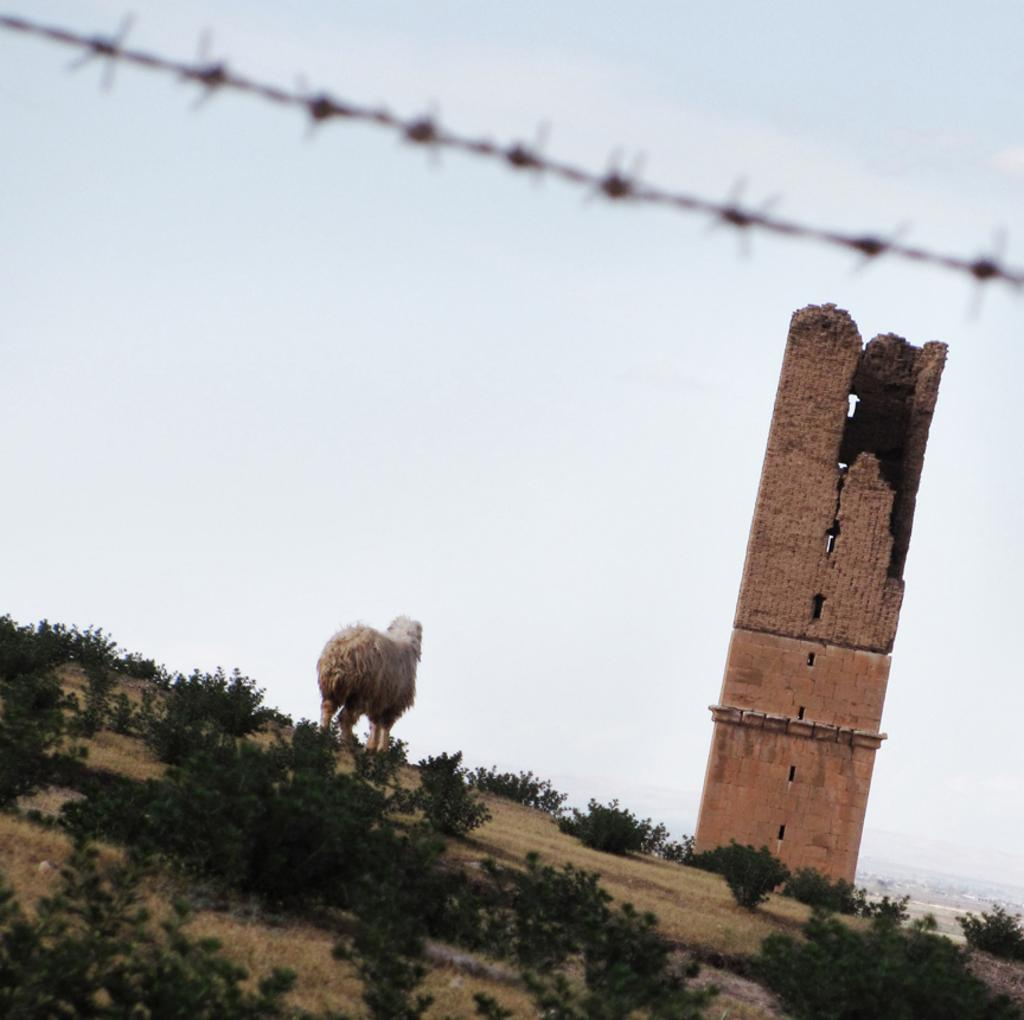What is the main subject in the foreground of the image? There is an animal in the foreground of the image. What is the animal standing on? The animal is on grass and plants. What can be seen in the background of the image? There is a collapsed building, trees, wire, and the sky visible in the background of the image. Can you describe the setting of the image? The image might have been taken during the day, with the animal standing on grass and plants, and a collapsed building, trees, wire, and the sky visible in the background. What type of hat is the animal wearing in the image? There is no hat present in the image; the animal is not wearing any clothing or accessories. 